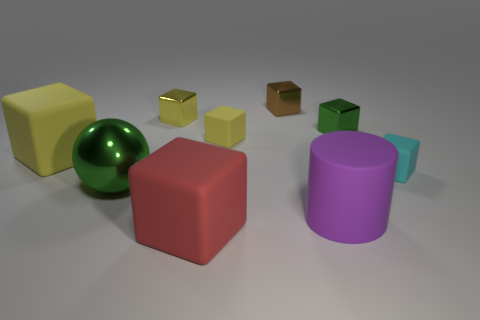Subtract all blue cylinders. How many yellow cubes are left? 3 Subtract all small cyan matte cubes. How many cubes are left? 6 Subtract 3 blocks. How many blocks are left? 4 Subtract all cyan blocks. How many blocks are left? 6 Subtract all gray cubes. Subtract all cyan cylinders. How many cubes are left? 7 Add 1 small gray metallic cubes. How many objects exist? 10 Subtract all balls. How many objects are left? 8 Add 1 blue rubber balls. How many blue rubber balls exist? 1 Subtract 1 yellow blocks. How many objects are left? 8 Subtract all rubber things. Subtract all cylinders. How many objects are left? 3 